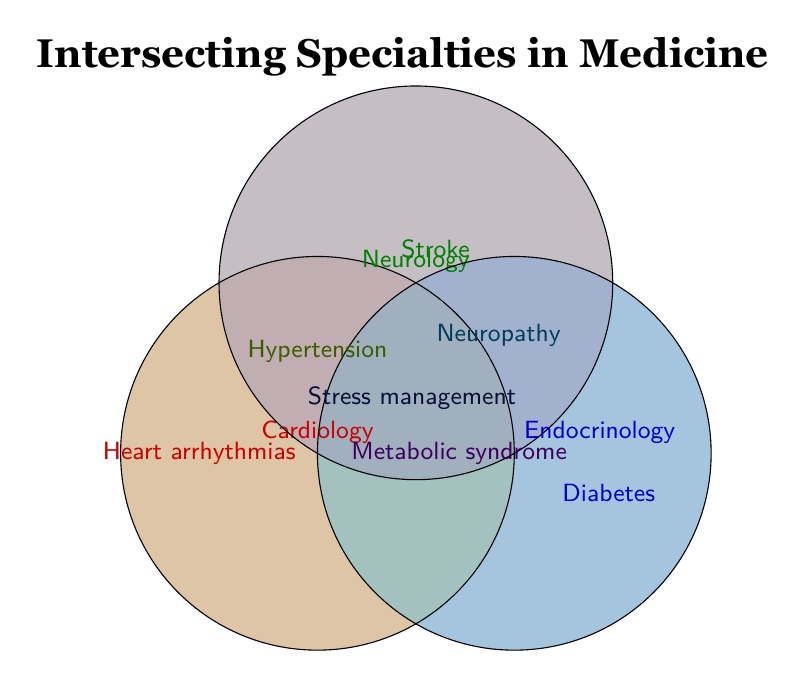What are the three specialties mentioned in the Venn Diagram? The Venn Diagram labels three intersecting circles, each representing a specialty: Cardiology, Neurology, and Endocrinology.
Answer: Cardiology, Neurology, Endocrinology Which specialty is associated with "Diabetes"? The figure shows that "Diabetes" is placed within the circle labeled "Endocrinology".
Answer: Endocrinology What condition is shared by Cardiology and Neurology but not Endocrinology? The area where the Cardiology and Neurology circles intersect, excluding the Endocrinology circle, contains "Hypertension".
Answer: Hypertension How many conditions are listed that involve more than one specialty? Areas of intersection display the conditions "Hypertension", "Metabolic syndrome", "Neuropathy", and "Stress management", totaling four conditions.
Answer: Four What is the intersection of all three specialties? The area where all three circles intersect has "Stress management".
Answer: Stress management Which specialty handles "Heart arrhythmias"? "Heart arrhythmias" is located within the circle for Cardiology only.
Answer: Cardiology Compared to Cardiology and Neurology, which specialty also deals with "Metabolic syndrome"? "Metabolic syndrome" is placed at the intersection of Cardiology and Endocrinology, indicating both specialties deal with it.
Answer: Endocrinology Which condition is exclusively related to Neurology? The fragment solely within the Neurology circle includes "Stroke".
Answer: Stroke 